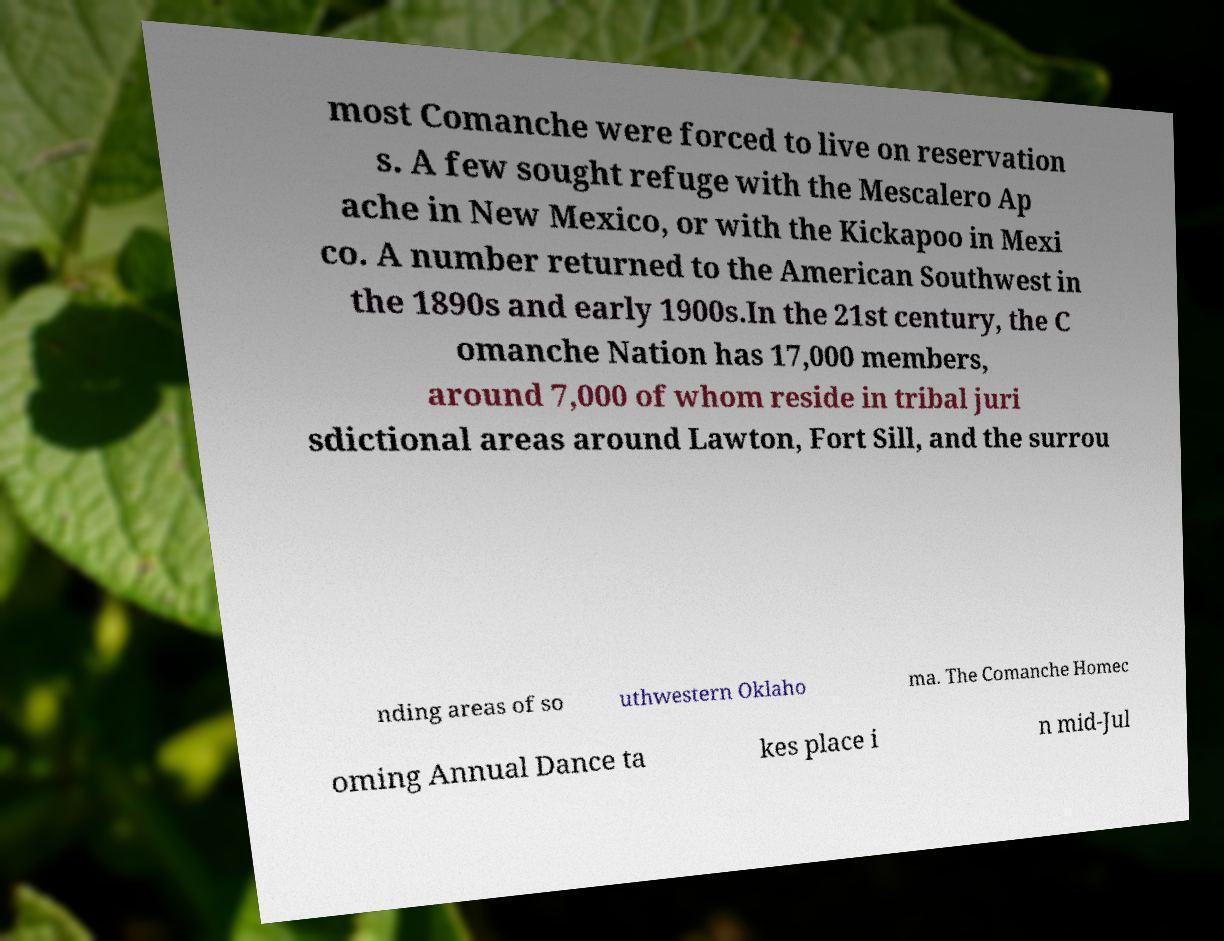I need the written content from this picture converted into text. Can you do that? most Comanche were forced to live on reservation s. A few sought refuge with the Mescalero Ap ache in New Mexico, or with the Kickapoo in Mexi co. A number returned to the American Southwest in the 1890s and early 1900s.In the 21st century, the C omanche Nation has 17,000 members, around 7,000 of whom reside in tribal juri sdictional areas around Lawton, Fort Sill, and the surrou nding areas of so uthwestern Oklaho ma. The Comanche Homec oming Annual Dance ta kes place i n mid-Jul 